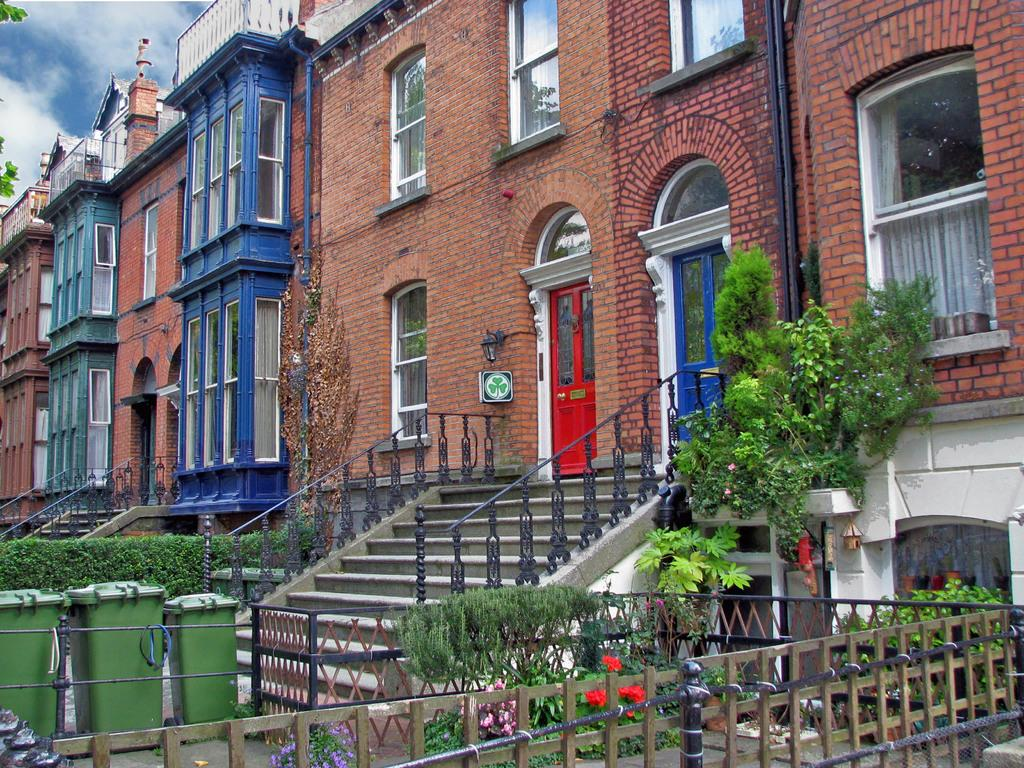What type of structure is visible in the image? There is a building with windows in the image. How would you describe the weather based on the image? The sky is cloudy in the image. What architectural feature is present in front of the building? There are steps in front of the building. What objects are placed near the building? There are bins and a fence in front of the building. What type of vegetation is present in front of the building? There are plants with flowers in front of the building. Can you see a kite flying in the sky in the image? There is no kite visible in the image; the sky is cloudy. Is there a robin perched on the fence in the image? There is no robin present in the image; only the building, steps, bins, fence, and plants with flowers are visible. 